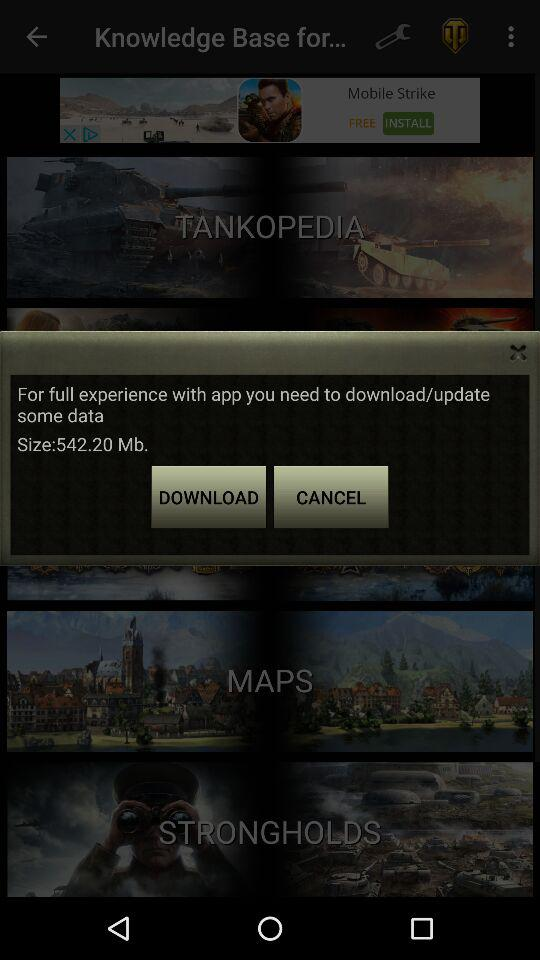What is the download/update data of the application? The download/update data is 542.20 Mb. 